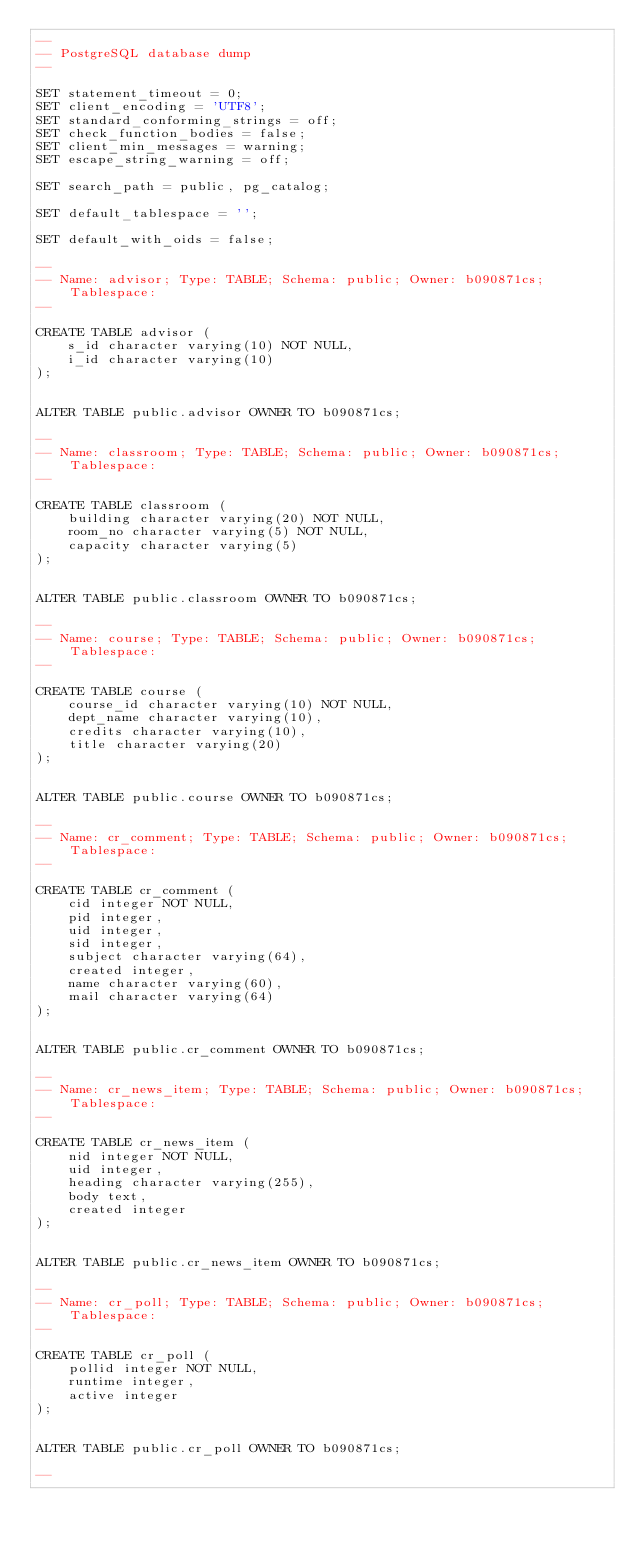Convert code to text. <code><loc_0><loc_0><loc_500><loc_500><_SQL_>--
-- PostgreSQL database dump
--

SET statement_timeout = 0;
SET client_encoding = 'UTF8';
SET standard_conforming_strings = off;
SET check_function_bodies = false;
SET client_min_messages = warning;
SET escape_string_warning = off;

SET search_path = public, pg_catalog;

SET default_tablespace = '';

SET default_with_oids = false;

--
-- Name: advisor; Type: TABLE; Schema: public; Owner: b090871cs; Tablespace: 
--

CREATE TABLE advisor (
    s_id character varying(10) NOT NULL,
    i_id character varying(10)
);


ALTER TABLE public.advisor OWNER TO b090871cs;

--
-- Name: classroom; Type: TABLE; Schema: public; Owner: b090871cs; Tablespace: 
--

CREATE TABLE classroom (
    building character varying(20) NOT NULL,
    room_no character varying(5) NOT NULL,
    capacity character varying(5)
);


ALTER TABLE public.classroom OWNER TO b090871cs;

--
-- Name: course; Type: TABLE; Schema: public; Owner: b090871cs; Tablespace: 
--

CREATE TABLE course (
    course_id character varying(10) NOT NULL,
    dept_name character varying(10),
    credits character varying(10),
    title character varying(20)
);


ALTER TABLE public.course OWNER TO b090871cs;

--
-- Name: cr_comment; Type: TABLE; Schema: public; Owner: b090871cs; Tablespace: 
--

CREATE TABLE cr_comment (
    cid integer NOT NULL,
    pid integer,
    uid integer,
    sid integer,
    subject character varying(64),
    created integer,
    name character varying(60),
    mail character varying(64)
);


ALTER TABLE public.cr_comment OWNER TO b090871cs;

--
-- Name: cr_news_item; Type: TABLE; Schema: public; Owner: b090871cs; Tablespace: 
--

CREATE TABLE cr_news_item (
    nid integer NOT NULL,
    uid integer,
    heading character varying(255),
    body text,
    created integer
);


ALTER TABLE public.cr_news_item OWNER TO b090871cs;

--
-- Name: cr_poll; Type: TABLE; Schema: public; Owner: b090871cs; Tablespace: 
--

CREATE TABLE cr_poll (
    pollid integer NOT NULL,
    runtime integer,
    active integer
);


ALTER TABLE public.cr_poll OWNER TO b090871cs;

--</code> 